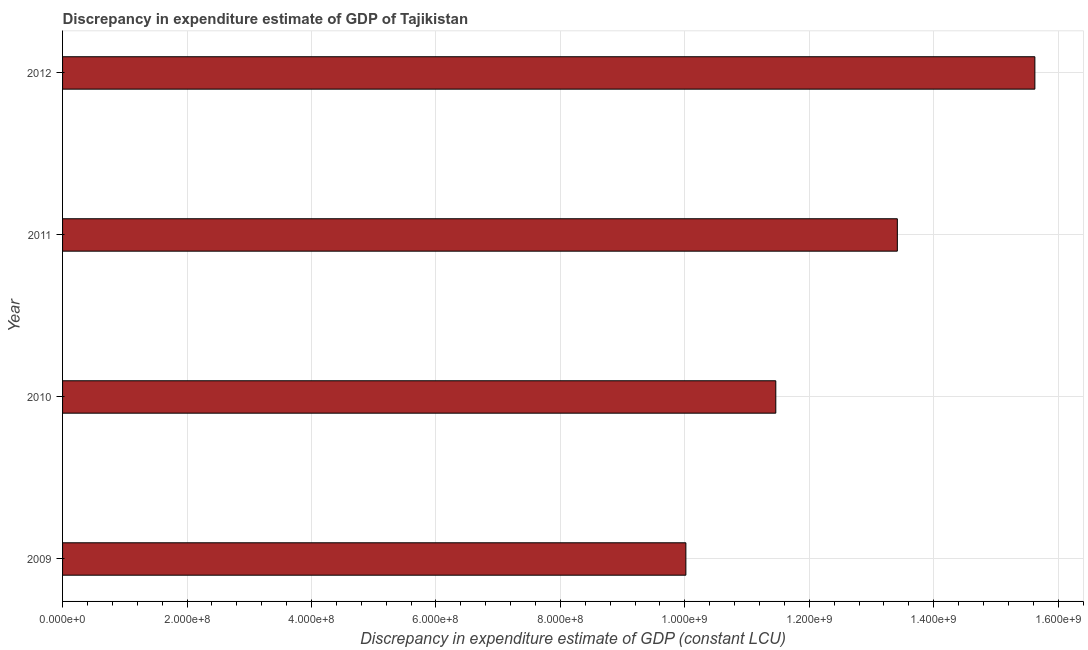What is the title of the graph?
Ensure brevity in your answer.  Discrepancy in expenditure estimate of GDP of Tajikistan. What is the label or title of the X-axis?
Provide a short and direct response. Discrepancy in expenditure estimate of GDP (constant LCU). What is the discrepancy in expenditure estimate of gdp in 2011?
Make the answer very short. 1.34e+09. Across all years, what is the maximum discrepancy in expenditure estimate of gdp?
Keep it short and to the point. 1.56e+09. Across all years, what is the minimum discrepancy in expenditure estimate of gdp?
Your response must be concise. 1.00e+09. In which year was the discrepancy in expenditure estimate of gdp maximum?
Your answer should be very brief. 2012. In which year was the discrepancy in expenditure estimate of gdp minimum?
Provide a succinct answer. 2009. What is the sum of the discrepancy in expenditure estimate of gdp?
Offer a very short reply. 5.05e+09. What is the difference between the discrepancy in expenditure estimate of gdp in 2011 and 2012?
Your answer should be very brief. -2.21e+08. What is the average discrepancy in expenditure estimate of gdp per year?
Provide a short and direct response. 1.26e+09. What is the median discrepancy in expenditure estimate of gdp?
Offer a very short reply. 1.24e+09. In how many years, is the discrepancy in expenditure estimate of gdp greater than 40000000 LCU?
Your answer should be compact. 4. Do a majority of the years between 2010 and 2012 (inclusive) have discrepancy in expenditure estimate of gdp greater than 440000000 LCU?
Your answer should be compact. Yes. What is the ratio of the discrepancy in expenditure estimate of gdp in 2010 to that in 2012?
Ensure brevity in your answer.  0.73. Is the difference between the discrepancy in expenditure estimate of gdp in 2009 and 2011 greater than the difference between any two years?
Offer a very short reply. No. What is the difference between the highest and the second highest discrepancy in expenditure estimate of gdp?
Keep it short and to the point. 2.21e+08. What is the difference between the highest and the lowest discrepancy in expenditure estimate of gdp?
Give a very brief answer. 5.61e+08. How many bars are there?
Provide a succinct answer. 4. Are the values on the major ticks of X-axis written in scientific E-notation?
Provide a short and direct response. Yes. What is the Discrepancy in expenditure estimate of GDP (constant LCU) of 2009?
Offer a very short reply. 1.00e+09. What is the Discrepancy in expenditure estimate of GDP (constant LCU) in 2010?
Give a very brief answer. 1.15e+09. What is the Discrepancy in expenditure estimate of GDP (constant LCU) in 2011?
Your answer should be compact. 1.34e+09. What is the Discrepancy in expenditure estimate of GDP (constant LCU) of 2012?
Your answer should be very brief. 1.56e+09. What is the difference between the Discrepancy in expenditure estimate of GDP (constant LCU) in 2009 and 2010?
Offer a very short reply. -1.44e+08. What is the difference between the Discrepancy in expenditure estimate of GDP (constant LCU) in 2009 and 2011?
Your response must be concise. -3.40e+08. What is the difference between the Discrepancy in expenditure estimate of GDP (constant LCU) in 2009 and 2012?
Offer a very short reply. -5.61e+08. What is the difference between the Discrepancy in expenditure estimate of GDP (constant LCU) in 2010 and 2011?
Give a very brief answer. -1.95e+08. What is the difference between the Discrepancy in expenditure estimate of GDP (constant LCU) in 2010 and 2012?
Provide a succinct answer. -4.16e+08. What is the difference between the Discrepancy in expenditure estimate of GDP (constant LCU) in 2011 and 2012?
Your response must be concise. -2.21e+08. What is the ratio of the Discrepancy in expenditure estimate of GDP (constant LCU) in 2009 to that in 2010?
Make the answer very short. 0.87. What is the ratio of the Discrepancy in expenditure estimate of GDP (constant LCU) in 2009 to that in 2011?
Provide a short and direct response. 0.75. What is the ratio of the Discrepancy in expenditure estimate of GDP (constant LCU) in 2009 to that in 2012?
Offer a terse response. 0.64. What is the ratio of the Discrepancy in expenditure estimate of GDP (constant LCU) in 2010 to that in 2011?
Your answer should be very brief. 0.85. What is the ratio of the Discrepancy in expenditure estimate of GDP (constant LCU) in 2010 to that in 2012?
Your response must be concise. 0.73. What is the ratio of the Discrepancy in expenditure estimate of GDP (constant LCU) in 2011 to that in 2012?
Your answer should be compact. 0.86. 